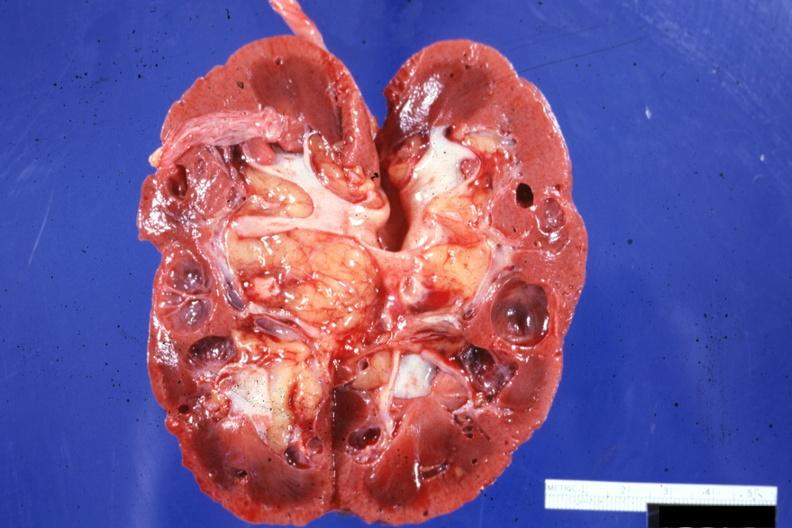does this image show cut surface?
Answer the question using a single word or phrase. Yes 